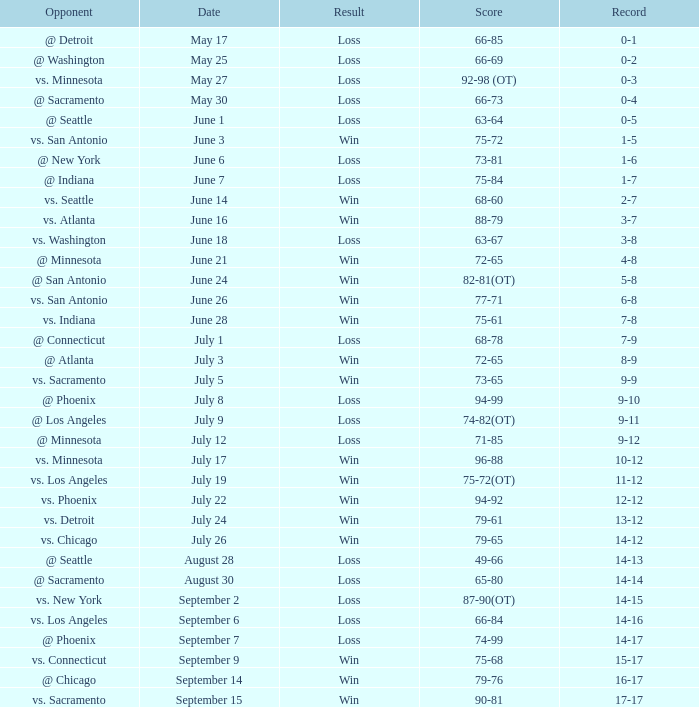What is the Record on July 12? 9-12. 